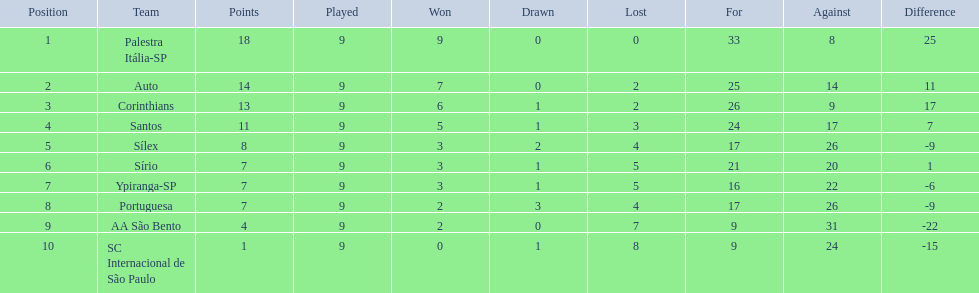Can you name the team that did not experience any defeats? Palestra Itália-SP. 